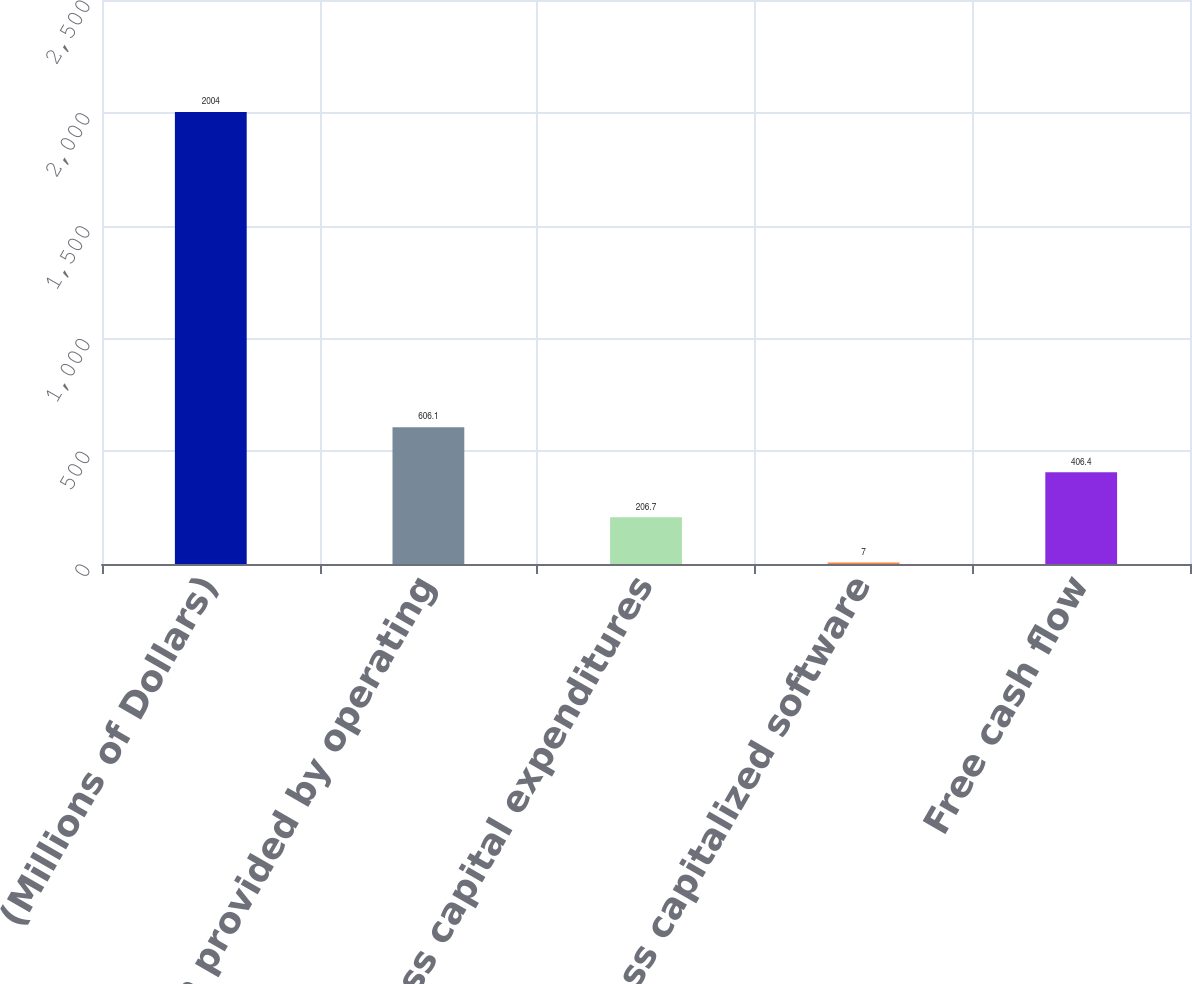Convert chart to OTSL. <chart><loc_0><loc_0><loc_500><loc_500><bar_chart><fcel>(Millions of Dollars)<fcel>net cash provided by operating<fcel>less capital expenditures<fcel>less capitalized software<fcel>Free cash flow<nl><fcel>2004<fcel>606.1<fcel>206.7<fcel>7<fcel>406.4<nl></chart> 